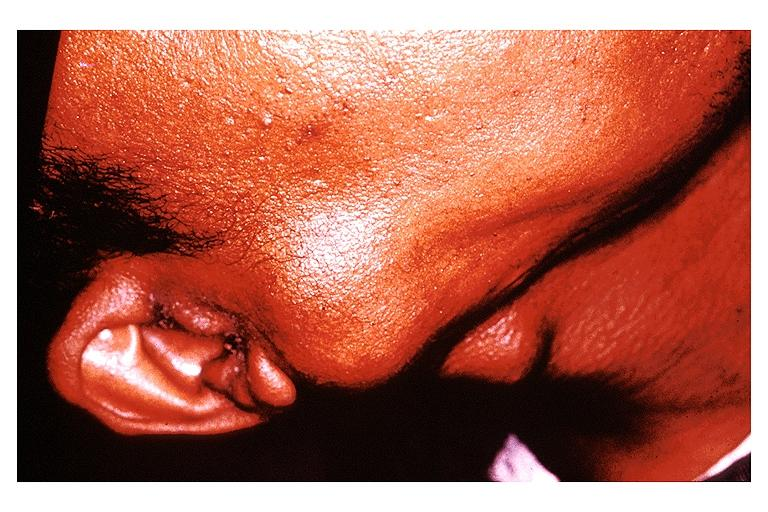where is this?
Answer the question using a single word or phrase. Oral 